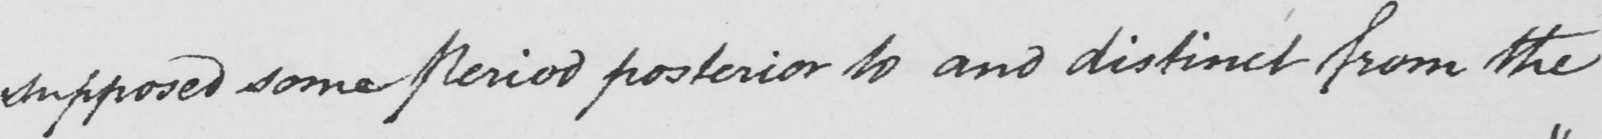Can you tell me what this handwritten text says? supposed some Period posterior to and distinct from the 